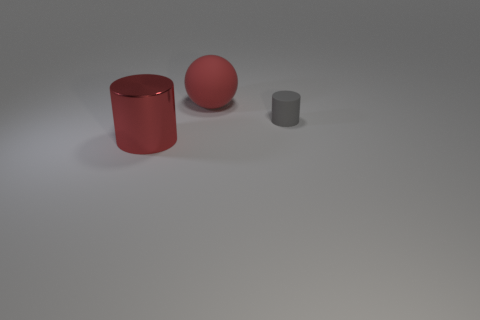Add 1 small gray cylinders. How many objects exist? 4 Subtract all cylinders. How many objects are left? 1 Add 3 large cyan metallic spheres. How many large cyan metallic spheres exist? 3 Subtract 0 cyan balls. How many objects are left? 3 Subtract all large blue cubes. Subtract all small gray matte things. How many objects are left? 2 Add 1 red rubber balls. How many red rubber balls are left? 2 